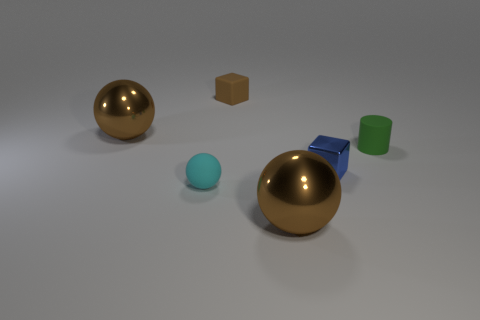How many other objects are there of the same shape as the blue shiny object?
Give a very brief answer. 1. There is a large metal object in front of the small green cylinder; what is its color?
Give a very brief answer. Brown. Do the cyan matte ball and the shiny cube have the same size?
Your answer should be compact. Yes. What material is the tiny cube left of the big sphere in front of the tiny green cylinder?
Your answer should be compact. Rubber. What number of small cylinders have the same color as the small ball?
Keep it short and to the point. 0. Is the number of brown things that are behind the small metal thing less than the number of large things?
Offer a very short reply. No. There is a object that is in front of the small cyan matte ball that is to the left of the brown rubber cube; what color is it?
Give a very brief answer. Brown. There is a brown thing to the left of the cyan object that is on the left side of the shiny object that is in front of the metal cube; what size is it?
Make the answer very short. Large. Are there fewer tiny objects on the left side of the small green matte object than green cylinders that are in front of the small cyan ball?
Offer a terse response. No. What number of brown things have the same material as the cyan object?
Your answer should be very brief. 1. 